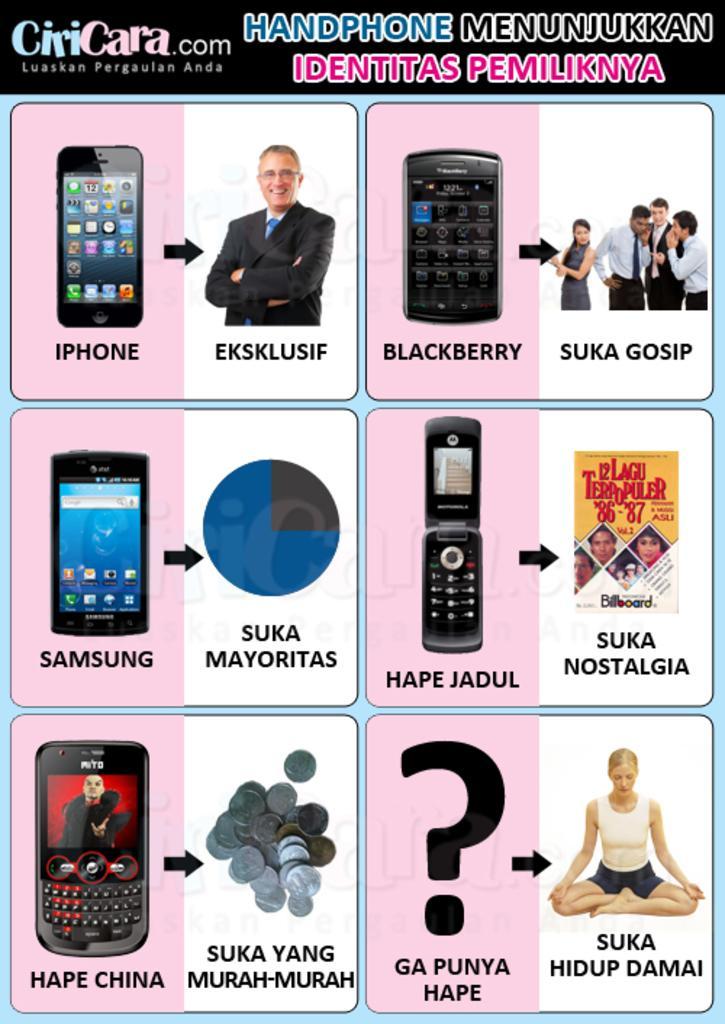Could you give a brief overview of what you see in this image? This image consists of a poster. On this, I can see few images of mobiles and persons and also I can see the text. 